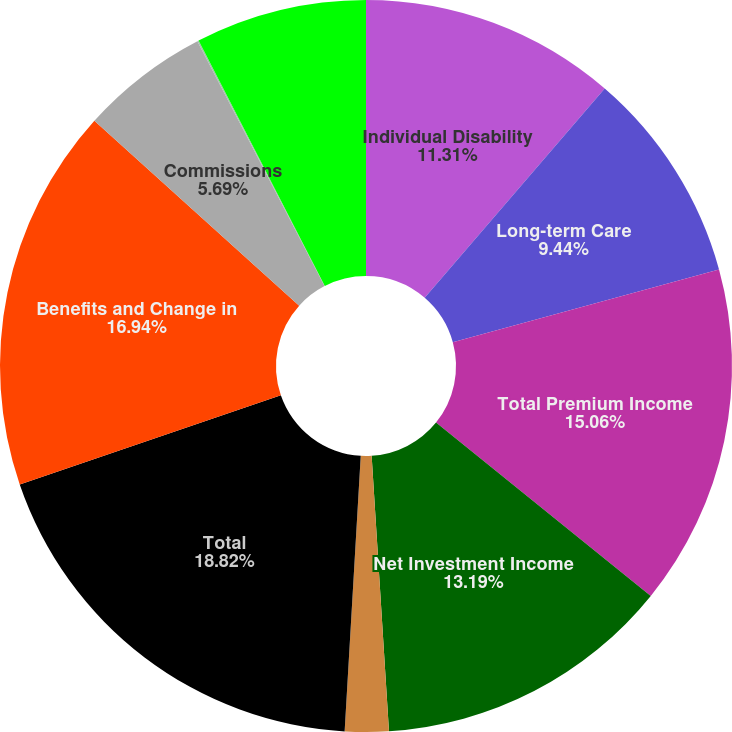Convert chart to OTSL. <chart><loc_0><loc_0><loc_500><loc_500><pie_chart><fcel>Individual Disability<fcel>Long-term Care<fcel>Total Premium Income<fcel>Net Investment Income<fcel>Other Income<fcel>Total<fcel>Benefits and Change in<fcel>Commissions<fcel>Interest and Debt Expense<fcel>Other Expenses<nl><fcel>11.31%<fcel>9.44%<fcel>15.06%<fcel>13.19%<fcel>1.93%<fcel>18.82%<fcel>16.94%<fcel>5.69%<fcel>0.06%<fcel>7.56%<nl></chart> 